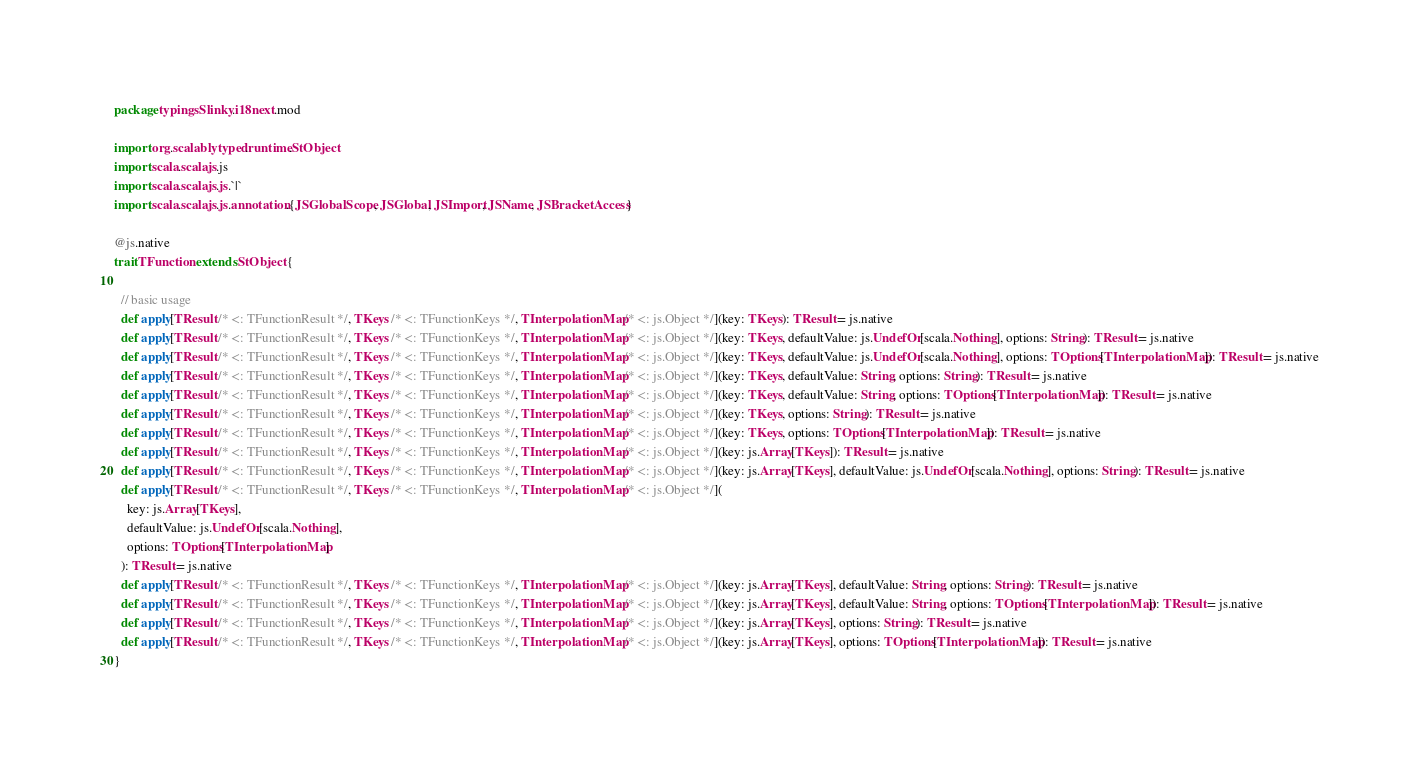<code> <loc_0><loc_0><loc_500><loc_500><_Scala_>package typingsSlinky.i18next.mod

import org.scalablytyped.runtime.StObject
import scala.scalajs.js
import scala.scalajs.js.`|`
import scala.scalajs.js.annotation.{JSGlobalScope, JSGlobal, JSImport, JSName, JSBracketAccess}

@js.native
trait TFunction extends StObject {
  
  // basic usage
  def apply[TResult /* <: TFunctionResult */, TKeys /* <: TFunctionKeys */, TInterpolationMap /* <: js.Object */](key: TKeys): TResult = js.native
  def apply[TResult /* <: TFunctionResult */, TKeys /* <: TFunctionKeys */, TInterpolationMap /* <: js.Object */](key: TKeys, defaultValue: js.UndefOr[scala.Nothing], options: String): TResult = js.native
  def apply[TResult /* <: TFunctionResult */, TKeys /* <: TFunctionKeys */, TInterpolationMap /* <: js.Object */](key: TKeys, defaultValue: js.UndefOr[scala.Nothing], options: TOptions[TInterpolationMap]): TResult = js.native
  def apply[TResult /* <: TFunctionResult */, TKeys /* <: TFunctionKeys */, TInterpolationMap /* <: js.Object */](key: TKeys, defaultValue: String, options: String): TResult = js.native
  def apply[TResult /* <: TFunctionResult */, TKeys /* <: TFunctionKeys */, TInterpolationMap /* <: js.Object */](key: TKeys, defaultValue: String, options: TOptions[TInterpolationMap]): TResult = js.native
  def apply[TResult /* <: TFunctionResult */, TKeys /* <: TFunctionKeys */, TInterpolationMap /* <: js.Object */](key: TKeys, options: String): TResult = js.native
  def apply[TResult /* <: TFunctionResult */, TKeys /* <: TFunctionKeys */, TInterpolationMap /* <: js.Object */](key: TKeys, options: TOptions[TInterpolationMap]): TResult = js.native
  def apply[TResult /* <: TFunctionResult */, TKeys /* <: TFunctionKeys */, TInterpolationMap /* <: js.Object */](key: js.Array[TKeys]): TResult = js.native
  def apply[TResult /* <: TFunctionResult */, TKeys /* <: TFunctionKeys */, TInterpolationMap /* <: js.Object */](key: js.Array[TKeys], defaultValue: js.UndefOr[scala.Nothing], options: String): TResult = js.native
  def apply[TResult /* <: TFunctionResult */, TKeys /* <: TFunctionKeys */, TInterpolationMap /* <: js.Object */](
    key: js.Array[TKeys],
    defaultValue: js.UndefOr[scala.Nothing],
    options: TOptions[TInterpolationMap]
  ): TResult = js.native
  def apply[TResult /* <: TFunctionResult */, TKeys /* <: TFunctionKeys */, TInterpolationMap /* <: js.Object */](key: js.Array[TKeys], defaultValue: String, options: String): TResult = js.native
  def apply[TResult /* <: TFunctionResult */, TKeys /* <: TFunctionKeys */, TInterpolationMap /* <: js.Object */](key: js.Array[TKeys], defaultValue: String, options: TOptions[TInterpolationMap]): TResult = js.native
  def apply[TResult /* <: TFunctionResult */, TKeys /* <: TFunctionKeys */, TInterpolationMap /* <: js.Object */](key: js.Array[TKeys], options: String): TResult = js.native
  def apply[TResult /* <: TFunctionResult */, TKeys /* <: TFunctionKeys */, TInterpolationMap /* <: js.Object */](key: js.Array[TKeys], options: TOptions[TInterpolationMap]): TResult = js.native
}
</code> 